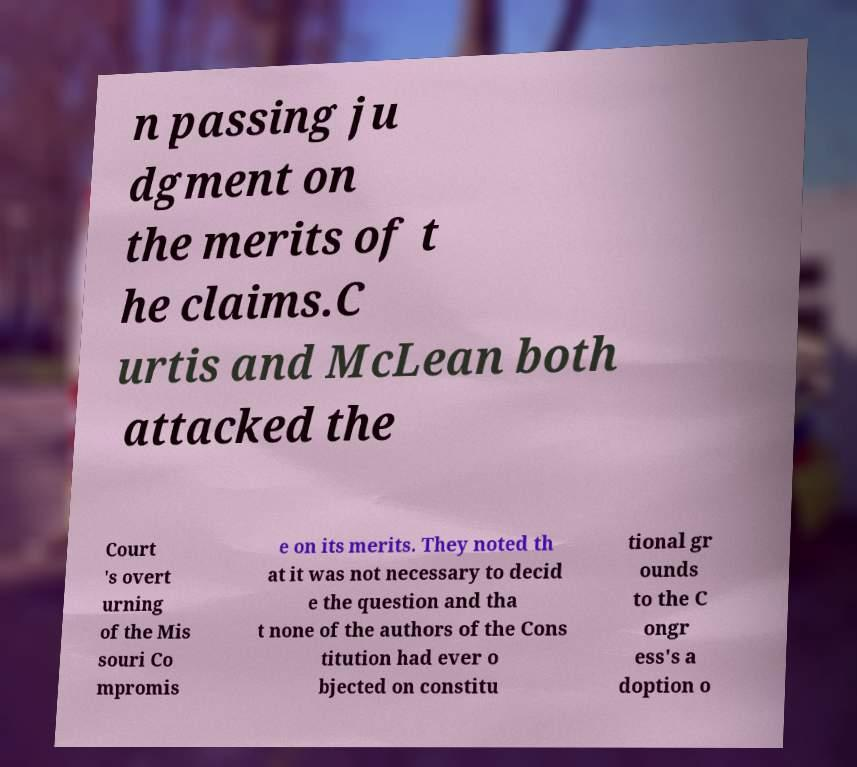There's text embedded in this image that I need extracted. Can you transcribe it verbatim? n passing ju dgment on the merits of t he claims.C urtis and McLean both attacked the Court 's overt urning of the Mis souri Co mpromis e on its merits. They noted th at it was not necessary to decid e the question and tha t none of the authors of the Cons titution had ever o bjected on constitu tional gr ounds to the C ongr ess's a doption o 